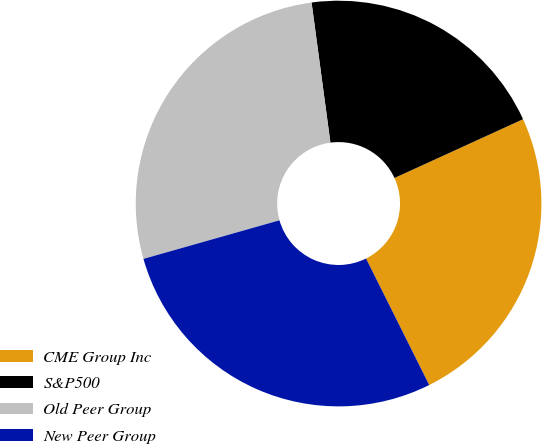Convert chart to OTSL. <chart><loc_0><loc_0><loc_500><loc_500><pie_chart><fcel>CME Group Inc<fcel>S&P500<fcel>Old Peer Group<fcel>New Peer Group<nl><fcel>24.45%<fcel>20.3%<fcel>27.27%<fcel>27.97%<nl></chart> 